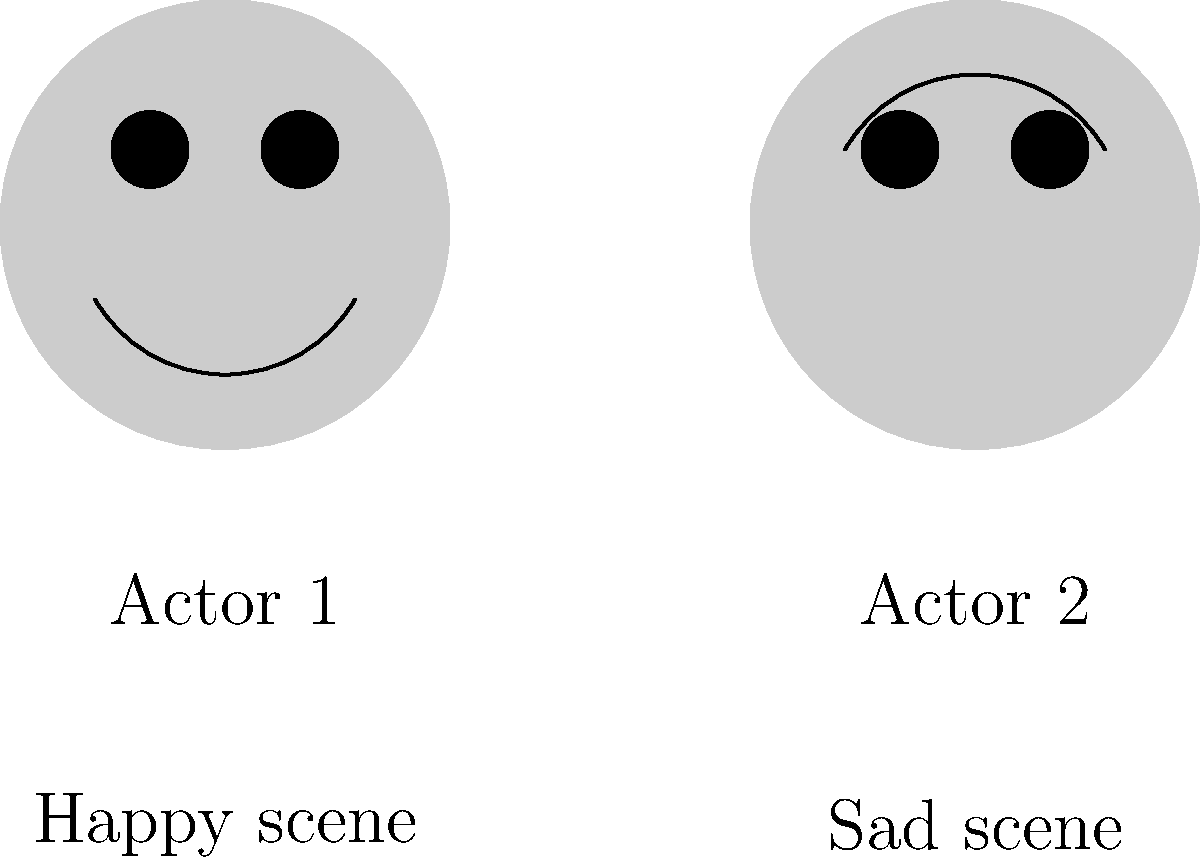In the graphic above, which actor's facial expression is more appropriate for a scene depicting intense joy in a Telugu movie? To answer this question, let's analyze the facial expressions of both actors:

1. Actor 1:
   - The mouth is curved upwards, forming a smile.
   - The eyes are open and round, indicating alertness and positivity.
   - The overall expression suggests happiness or joy.

2. Actor 2:
   - The mouth is curved downwards, forming a frown.
   - The eyes are open but slightly angled, suggesting concern or sadness.
   - The overall expression indicates sadness or disappointment.

3. Context:
   - The question asks about a scene depicting intense joy.
   - In Telugu cinema, emotions are often portrayed with exaggerated expressions for dramatic effect.

4. Comparison:
   - Actor 1's expression aligns with joy, while Actor 2's does not.
   - The upward curve of Actor 1's mouth is more suitable for expressing happiness.
   - Actor 1's wide eyes suggest excitement, which is consistent with intense joy.

5. Cultural consideration:
   - In Telugu cinema, a broad smile is often used to convey happiness and joy in emotional scenes.

Based on these observations, Actor 1's facial expression is more appropriate for a scene depicting intense joy in a Telugu movie.
Answer: Actor 1 